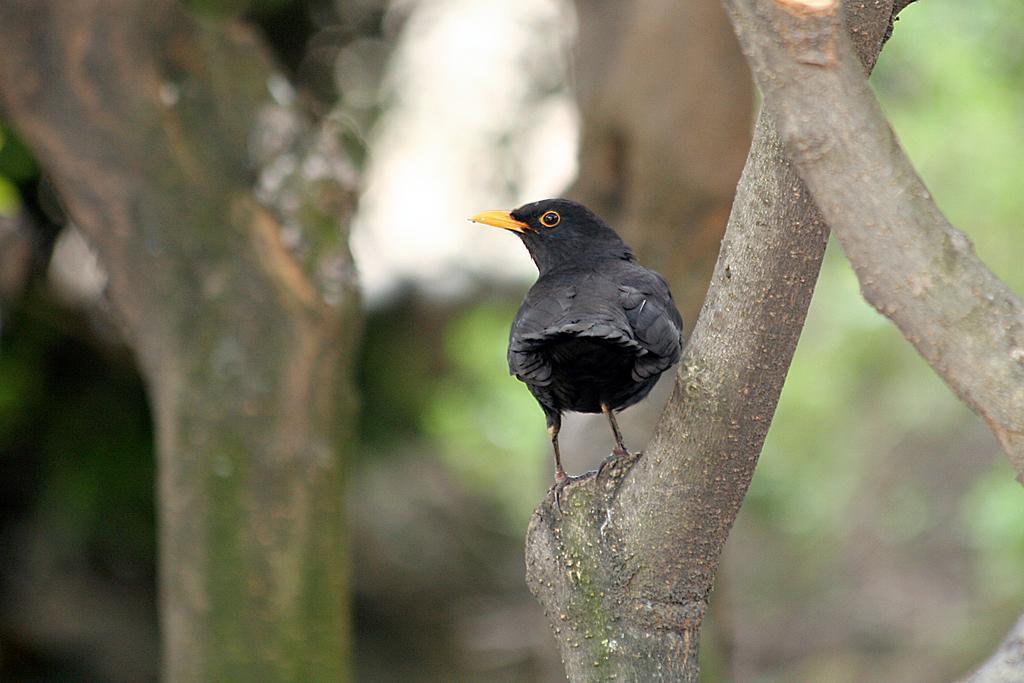How would you summarize this image in a sentence or two? In this image we can see a black color bird on the tree branch. The background of the image is blurred. 